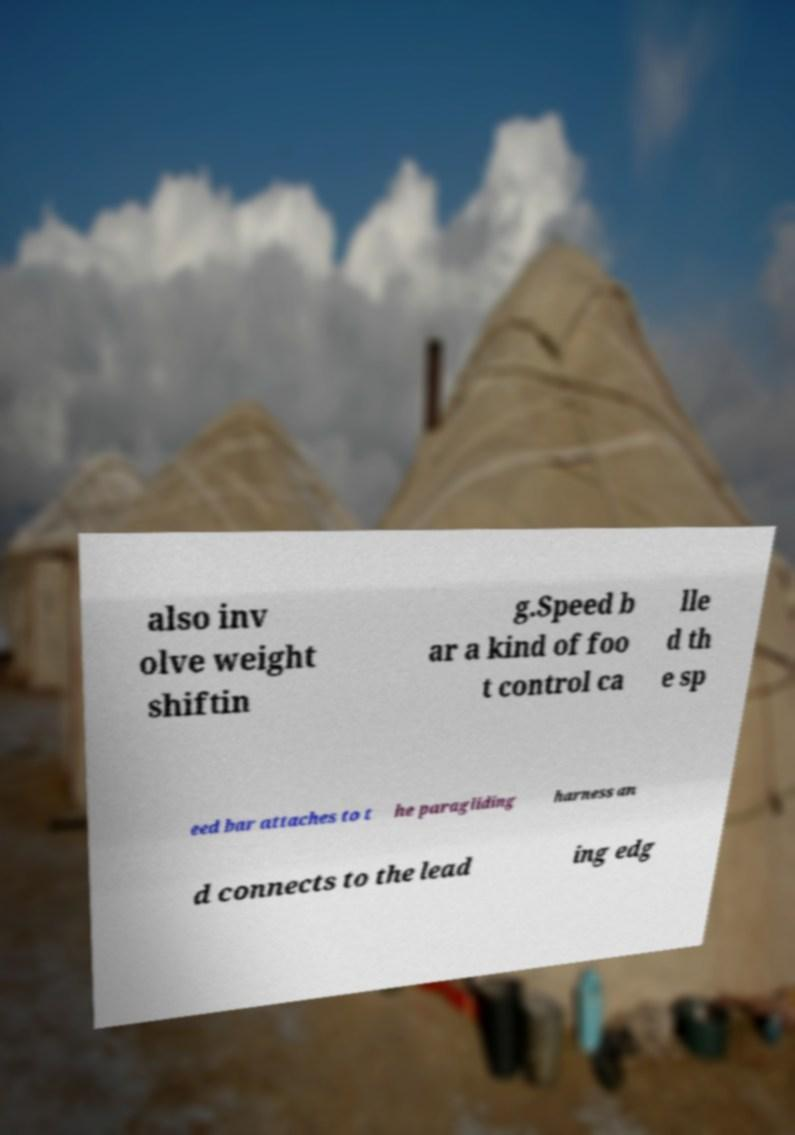Please read and relay the text visible in this image. What does it say? also inv olve weight shiftin g.Speed b ar a kind of foo t control ca lle d th e sp eed bar attaches to t he paragliding harness an d connects to the lead ing edg 